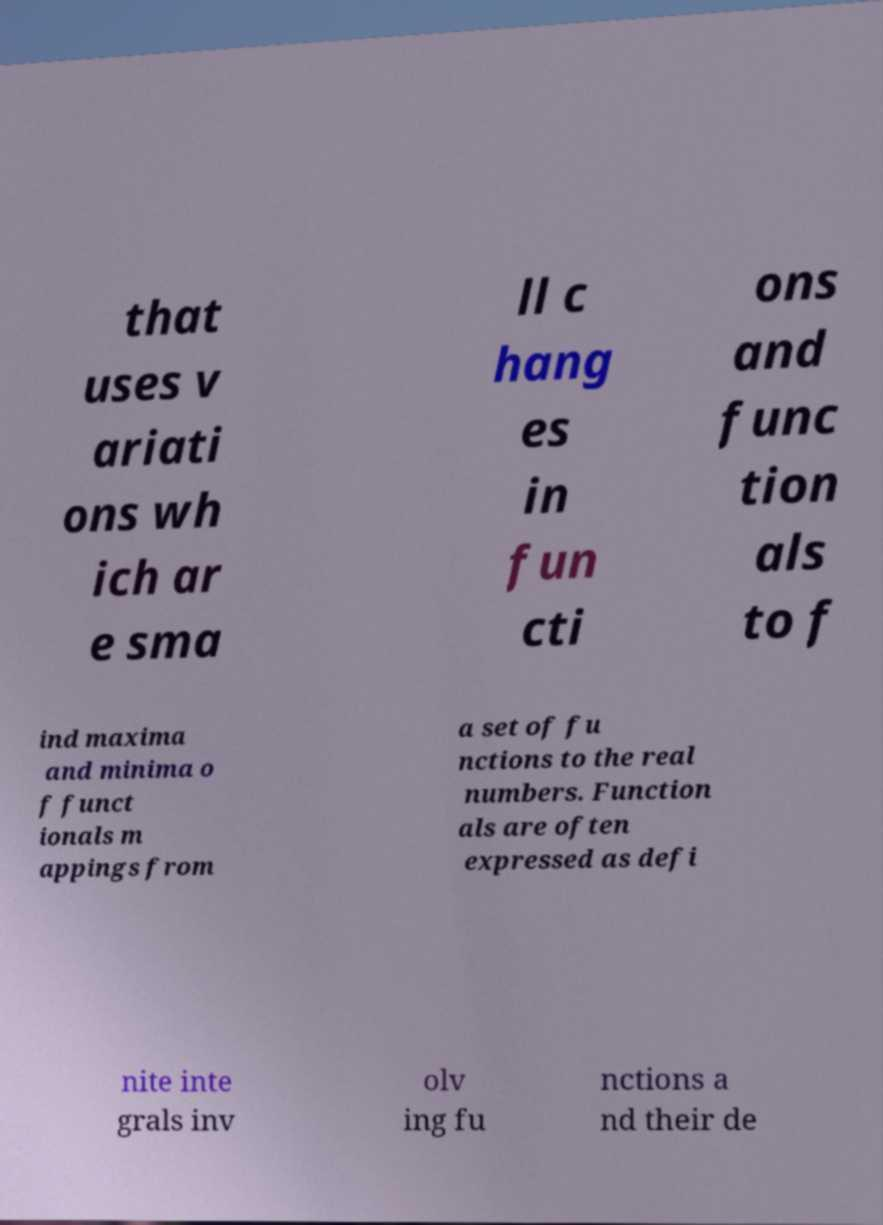There's text embedded in this image that I need extracted. Can you transcribe it verbatim? that uses v ariati ons wh ich ar e sma ll c hang es in fun cti ons and func tion als to f ind maxima and minima o f funct ionals m appings from a set of fu nctions to the real numbers. Function als are often expressed as defi nite inte grals inv olv ing fu nctions a nd their de 